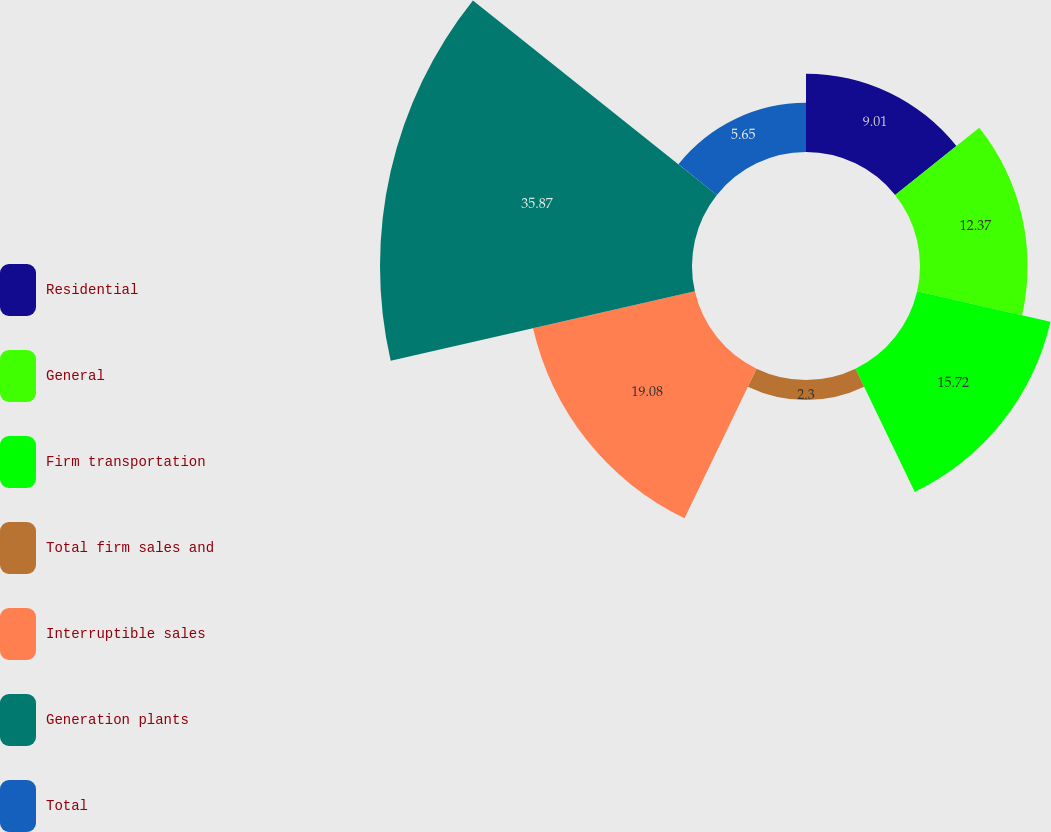Convert chart. <chart><loc_0><loc_0><loc_500><loc_500><pie_chart><fcel>Residential<fcel>General<fcel>Firm transportation<fcel>Total firm sales and<fcel>Interruptible sales<fcel>Generation plants<fcel>Total<nl><fcel>9.01%<fcel>12.37%<fcel>15.72%<fcel>2.3%<fcel>19.08%<fcel>35.87%<fcel>5.65%<nl></chart> 